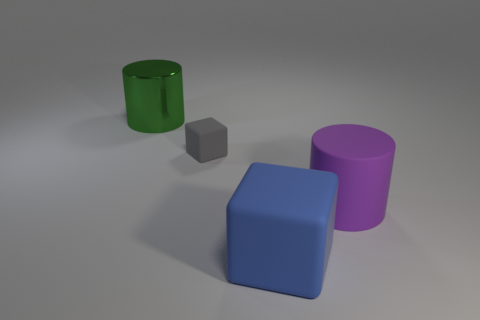Add 4 purple rubber cylinders. How many objects exist? 8 Add 3 tiny cubes. How many tiny cubes are left? 4 Add 4 small cubes. How many small cubes exist? 5 Subtract 0 red blocks. How many objects are left? 4 Subtract all red cylinders. Subtract all gray spheres. How many cylinders are left? 2 Subtract all large gray metallic cubes. Subtract all purple matte things. How many objects are left? 3 